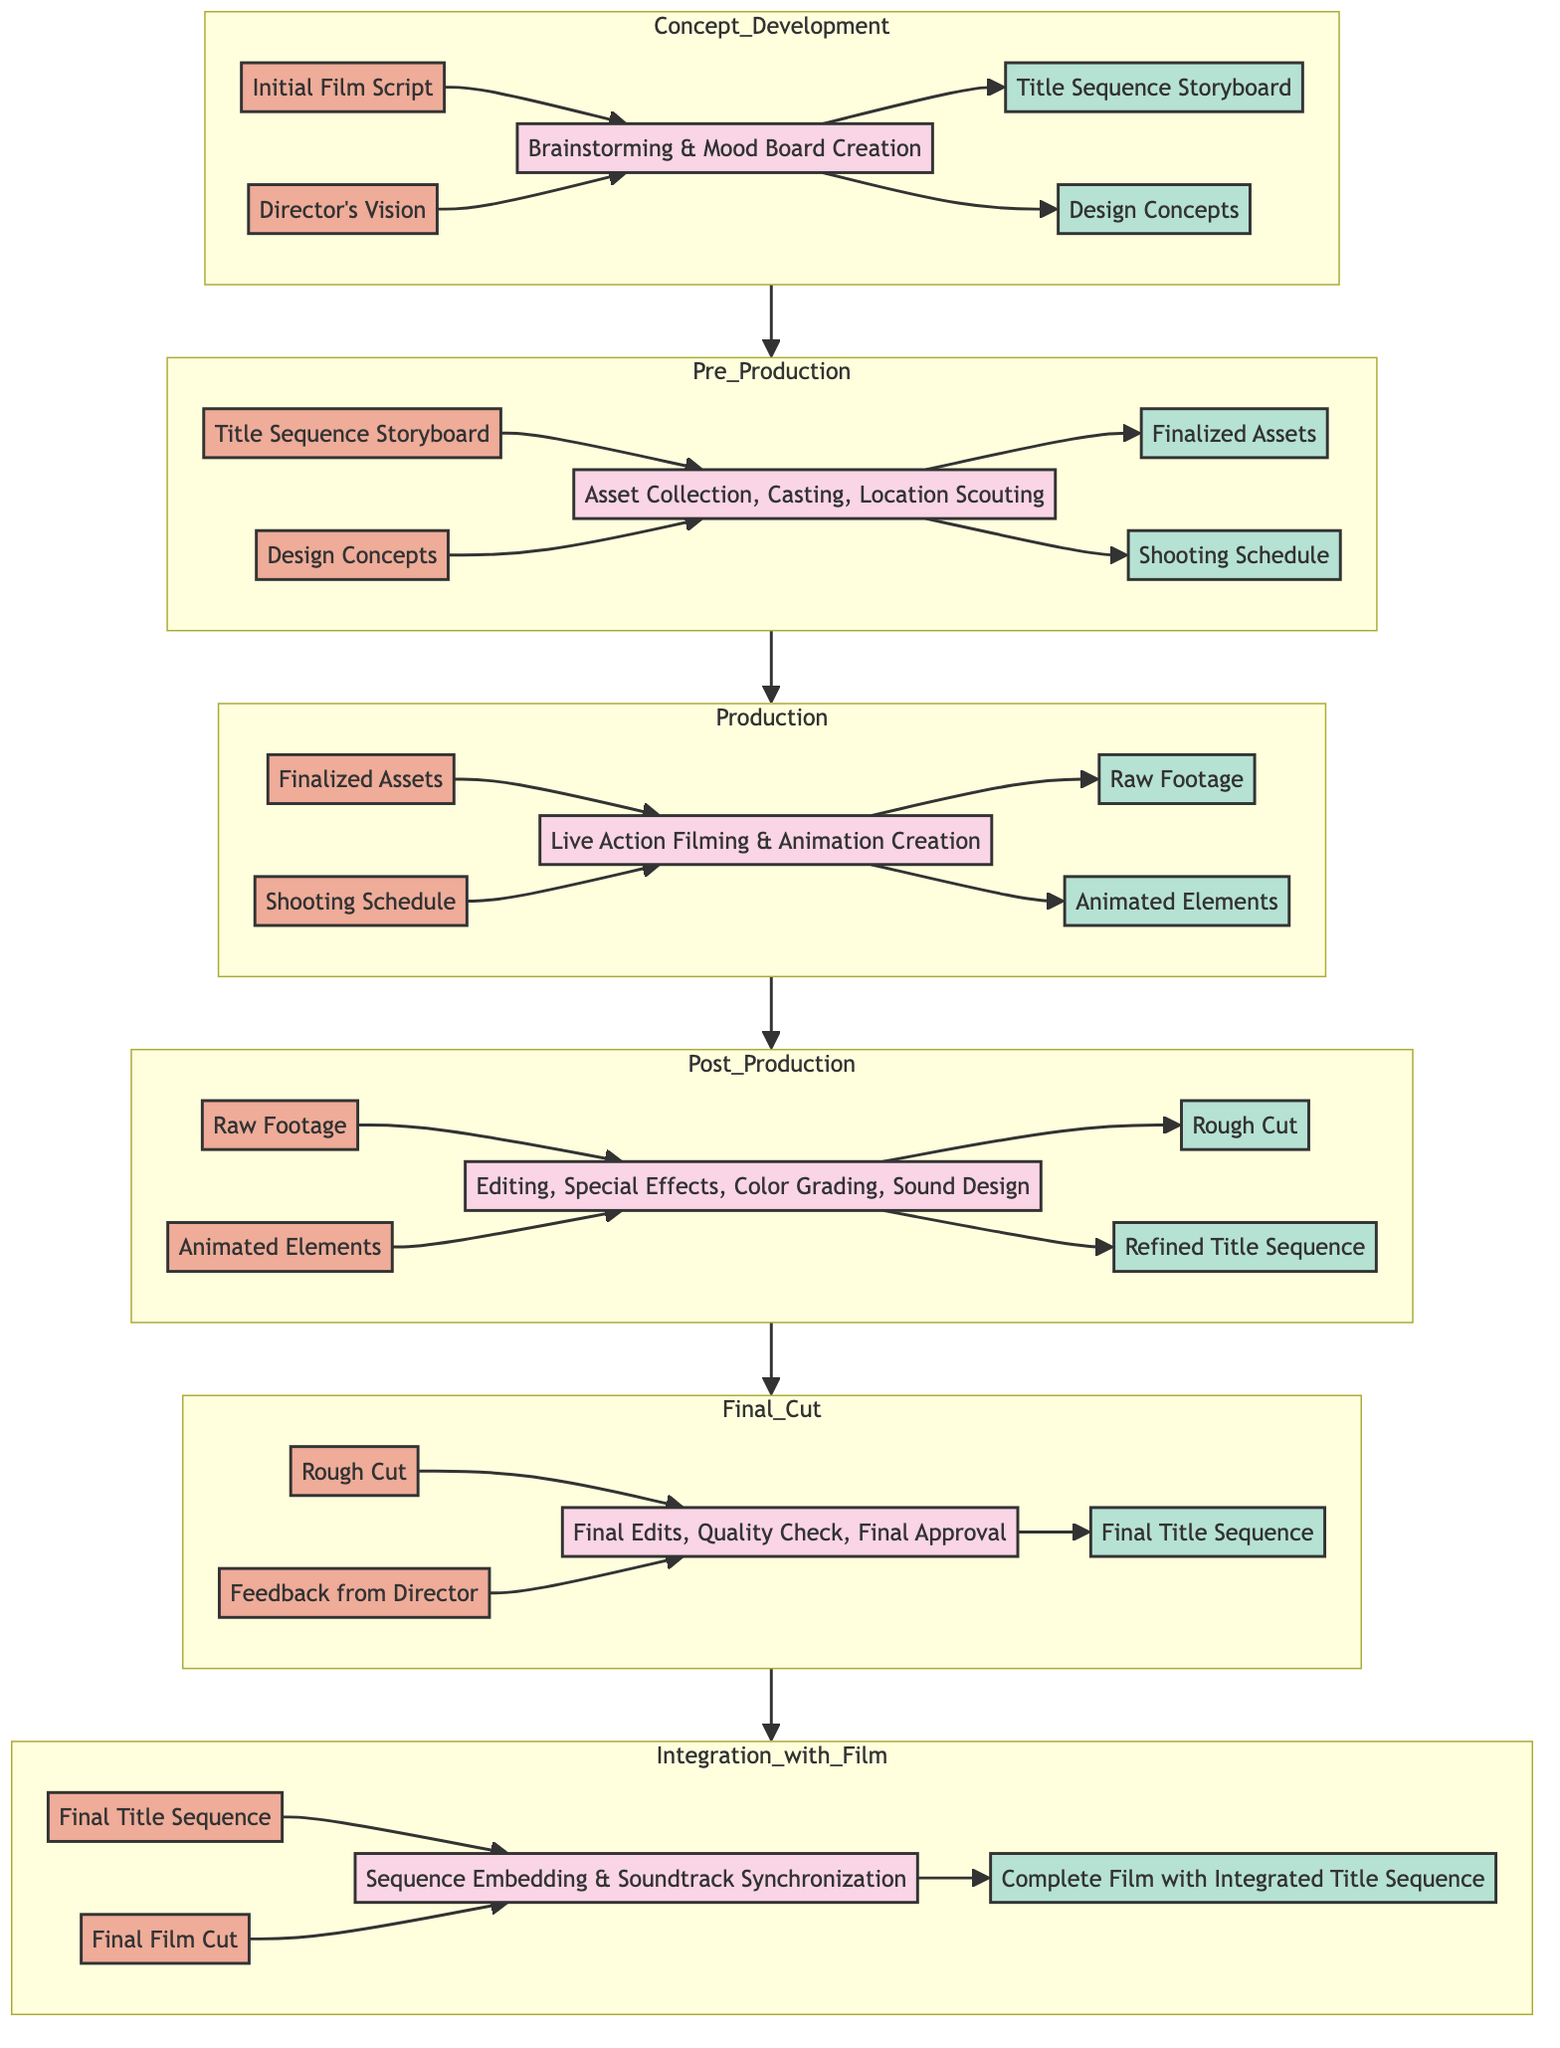What is the input for the Concept Development stage? The input for the Concept Development stage consists of "Initial Film Script" and "Director's Vision." These two elements are crucial for defining the creative direction and narrative focus of the title sequence.
Answer: Initial Film Script, Director's Vision What is the output of the Post Production phase? The output of the Post Production phase includes "Rough Cut" and "Refined Title Sequence." These are the results of editing, adding special effects, and making color grades, which are central to finalizing the title sequence before it moves to the Final Cut stage.
Answer: Rough Cut, Refined Title Sequence How many processes are in the Pre Production stage? In the Pre Production stage, there are three processes: "Asset Collection," "Casting," and "Location Scouting." These processes involve gathering everything necessary for the production of the title sequence successfully.
Answer: 3 What do the outputs of the Production stage include? The outputs of the Production stage comprise "Raw Footage" and "Animated Elements." This indicates that both live-action and animation work have been completed during this phase.
Answer: Raw Footage, Animated Elements What is the final output of the integration with film process? The final output of the integration with film process is "Complete Film with Integrated Title Sequence." This output signifies that the title sequence has been effectively incorporated into the overall film.
Answer: Complete Film with Integrated Title Sequence Which two inputs are required for the Final Cut stage? The two inputs required for the Final Cut stage are "Rough Cut" and "Feedback from Director." Both inputs are essential for making final adjustments and ensuring the title sequence aligns with the director's vision.
Answer: Rough Cut, Feedback from Director What is the first process in the Production stage? The first process in the Production stage is "Live Action Filming." This action initiates the filming of the title sequence using the finalized assets that have been prepared.
Answer: Live Action Filming How many total stages are there in the title sequence production workflow? There are five total stages in the title sequence production workflow: Concept Development, Pre Production, Production, Post Production, and Final Cut, culminating in integration with the film.
Answer: 6 